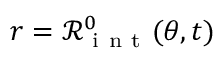<formula> <loc_0><loc_0><loc_500><loc_500>r = \mathcal { R } _ { i n t } ^ { 0 } ( \theta , t )</formula> 